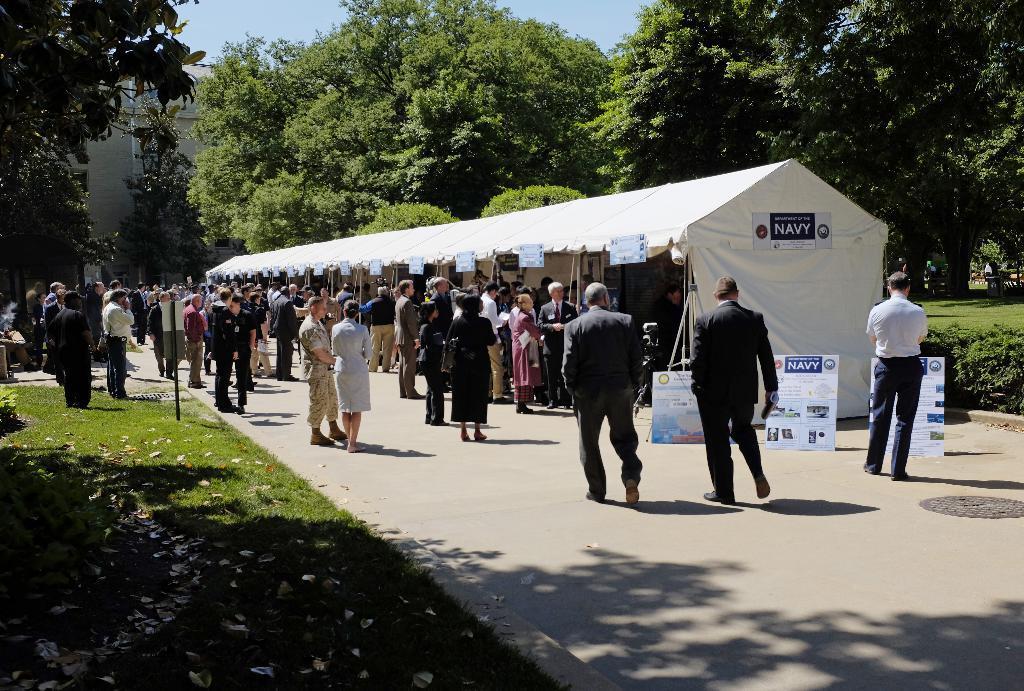How would you summarize this image in a sentence or two? In this picture we can see group of people, few are standing and few are walking, in front of them we can find few hoardings and a tent, in the background we can find few trees, on the left side of the image we can find a sign board and a metal rod. 